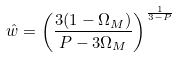Convert formula to latex. <formula><loc_0><loc_0><loc_500><loc_500>\hat { w } = \left ( \frac { 3 ( 1 - \Omega _ { M } ) } { P - 3 \Omega _ { M } } \right ) ^ { \frac { 1 } { 3 - P } }</formula> 